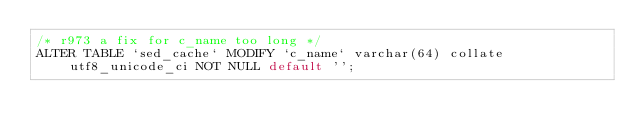<code> <loc_0><loc_0><loc_500><loc_500><_SQL_>/* r973 a fix for c_name too long */
ALTER TABLE `sed_cache` MODIFY `c_name` varchar(64) collate utf8_unicode_ci NOT NULL default '';</code> 